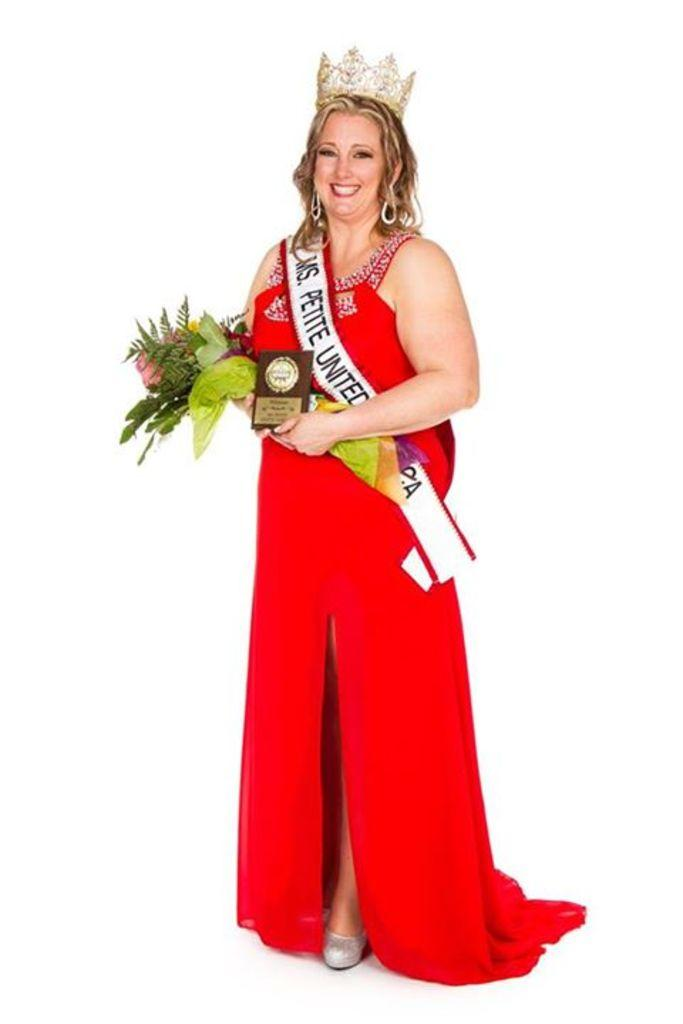Who is the main subject in the image? There is a lady in the image. What is the lady wearing? The lady is wearing a red dress. How does the lady look? The lady is stunning. What is the lady holding in her hands? The lady is holding a bouquet and an award. What is on the lady's head? There is a crown on the lady's head. What type of breakfast is the lady eating in the image? There is no breakfast present in the image; the lady is holding a bouquet and an award. Does the lady have a tail in the image? No, the lady does not have a tail in the image. 